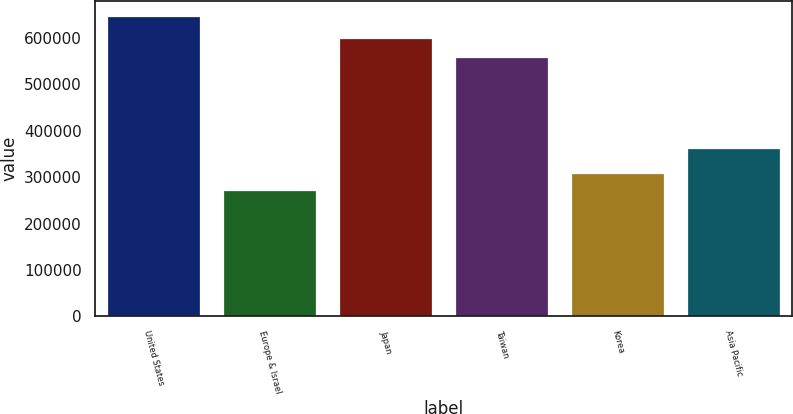Convert chart to OTSL. <chart><loc_0><loc_0><loc_500><loc_500><bar_chart><fcel>United States<fcel>Europe & Israel<fcel>Japan<fcel>Taiwan<fcel>Korea<fcel>Asia Pacific<nl><fcel>647813<fcel>271814<fcel>600861<fcel>559083<fcel>309414<fcel>362902<nl></chart> 